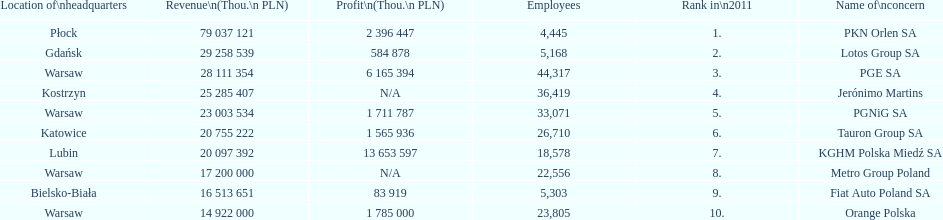What company is the only one with a revenue greater than 75,000,000 thou. pln? PKN Orlen SA. Could you parse the entire table? {'header': ['Location of\\nheadquarters', 'Revenue\\n(Thou.\\n\xa0PLN)', 'Profit\\n(Thou.\\n\xa0PLN)', 'Employees', 'Rank in\\n2011', 'Name of\\nconcern'], 'rows': [['Płock', '79 037 121', '2 396 447', '4,445', '1.', 'PKN Orlen SA'], ['Gdańsk', '29 258 539', '584 878', '5,168', '2.', 'Lotos Group SA'], ['Warsaw', '28 111 354', '6 165 394', '44,317', '3.', 'PGE SA'], ['Kostrzyn', '25 285 407', 'N/A', '36,419', '4.', 'Jerónimo Martins'], ['Warsaw', '23 003 534', '1 711 787', '33,071', '5.', 'PGNiG SA'], ['Katowice', '20 755 222', '1 565 936', '26,710', '6.', 'Tauron Group SA'], ['Lubin', '20 097 392', '13 653 597', '18,578', '7.', 'KGHM Polska Miedź SA'], ['Warsaw', '17 200 000', 'N/A', '22,556', '8.', 'Metro Group Poland'], ['Bielsko-Biała', '16 513 651', '83 919', '5,303', '9.', 'Fiat Auto Poland SA'], ['Warsaw', '14 922 000', '1 785 000', '23,805', '10.', 'Orange Polska']]} 